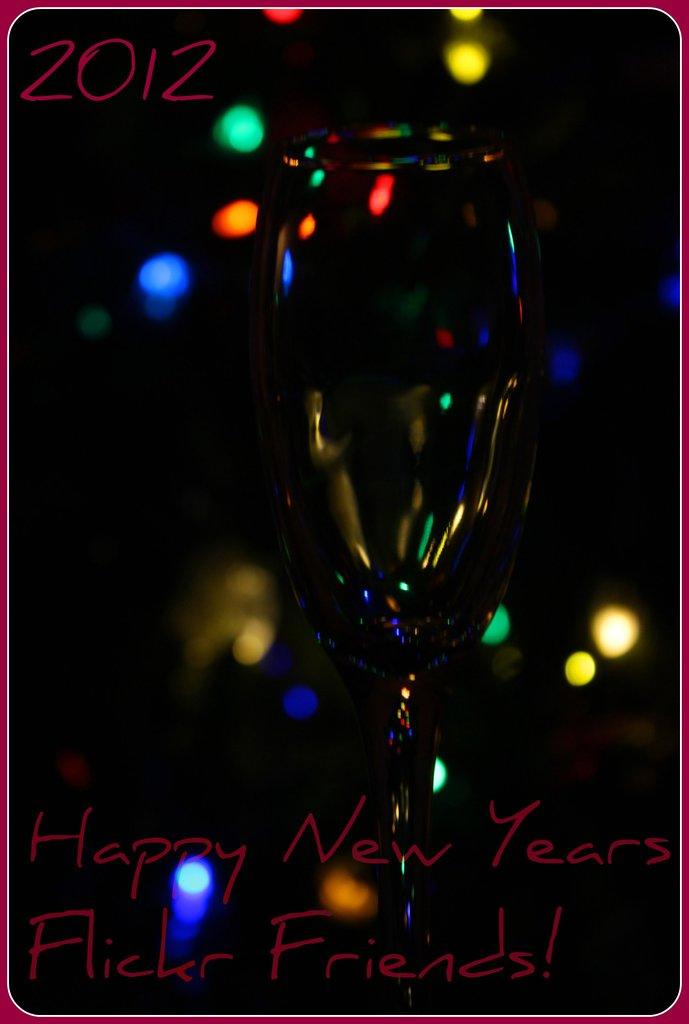What is present in the image? There is a poster in the image. Can you describe the colors used in the poster? The poster has black, orange, green, blue, and yellow colors. What is depicted on the poster? There is a wine glass depicted on the poster. Are there any words on the poster, and if so, what color are they? Yes, there are words written in red color on the poster. Can you tell me what time the queen is wearing a watch in the image? There is no queen or watch present in the image; it only features a poster with a wine glass and words written in red color. 